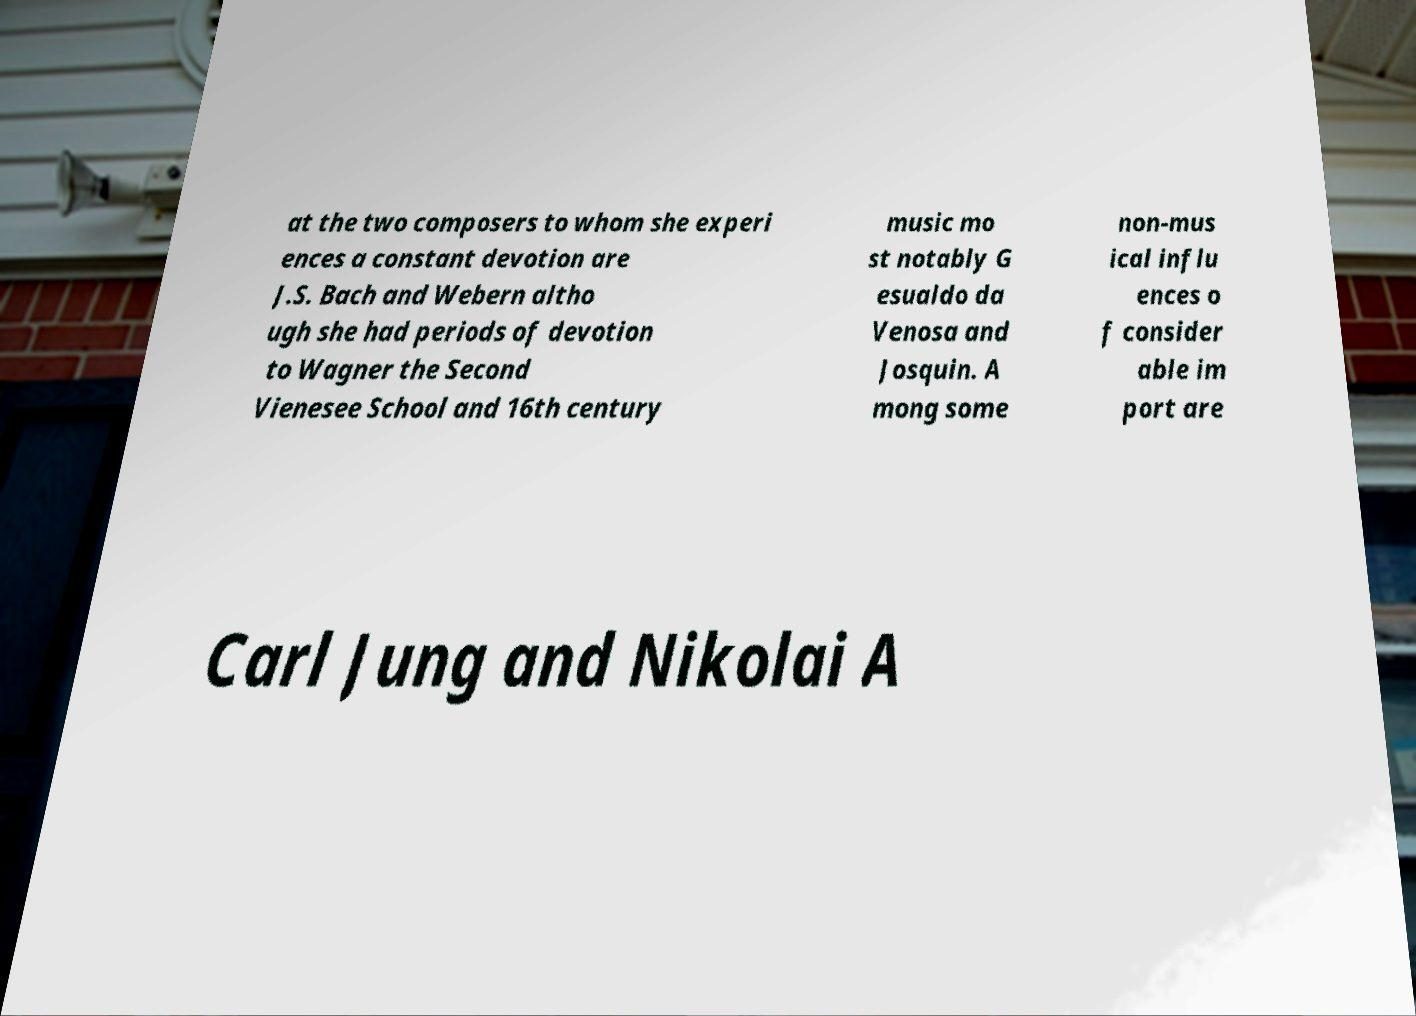There's text embedded in this image that I need extracted. Can you transcribe it verbatim? at the two composers to whom she experi ences a constant devotion are J.S. Bach and Webern altho ugh she had periods of devotion to Wagner the Second Vienesee School and 16th century music mo st notably G esualdo da Venosa and Josquin. A mong some non-mus ical influ ences o f consider able im port are Carl Jung and Nikolai A 